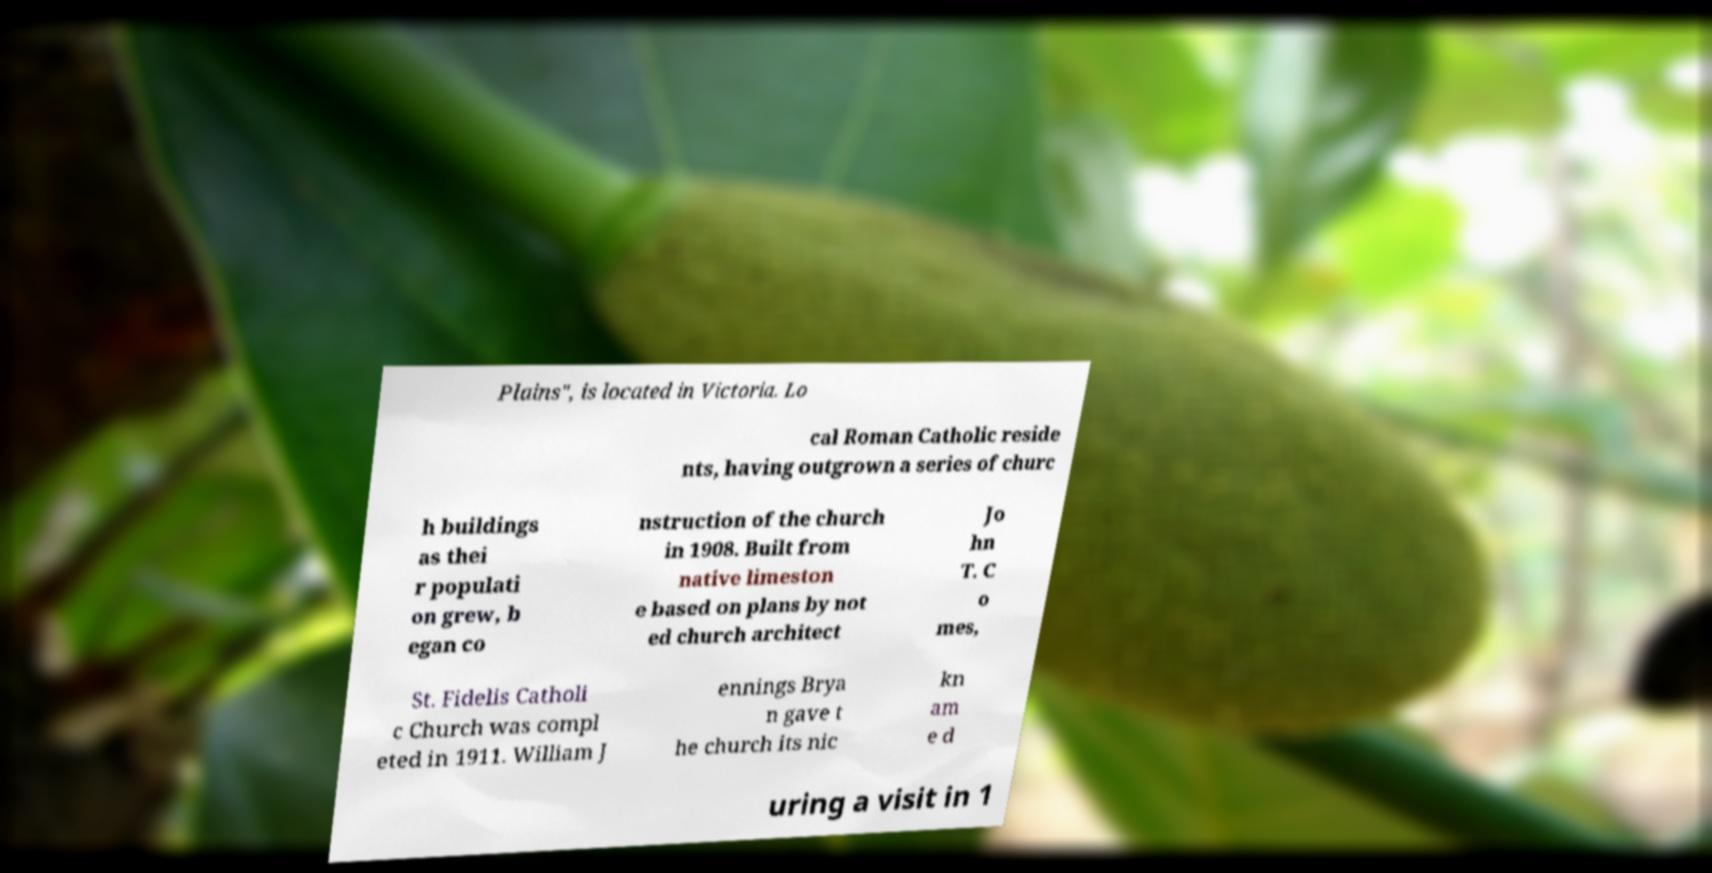There's text embedded in this image that I need extracted. Can you transcribe it verbatim? Plains", is located in Victoria. Lo cal Roman Catholic reside nts, having outgrown a series of churc h buildings as thei r populati on grew, b egan co nstruction of the church in 1908. Built from native limeston e based on plans by not ed church architect Jo hn T. C o mes, St. Fidelis Catholi c Church was compl eted in 1911. William J ennings Brya n gave t he church its nic kn am e d uring a visit in 1 